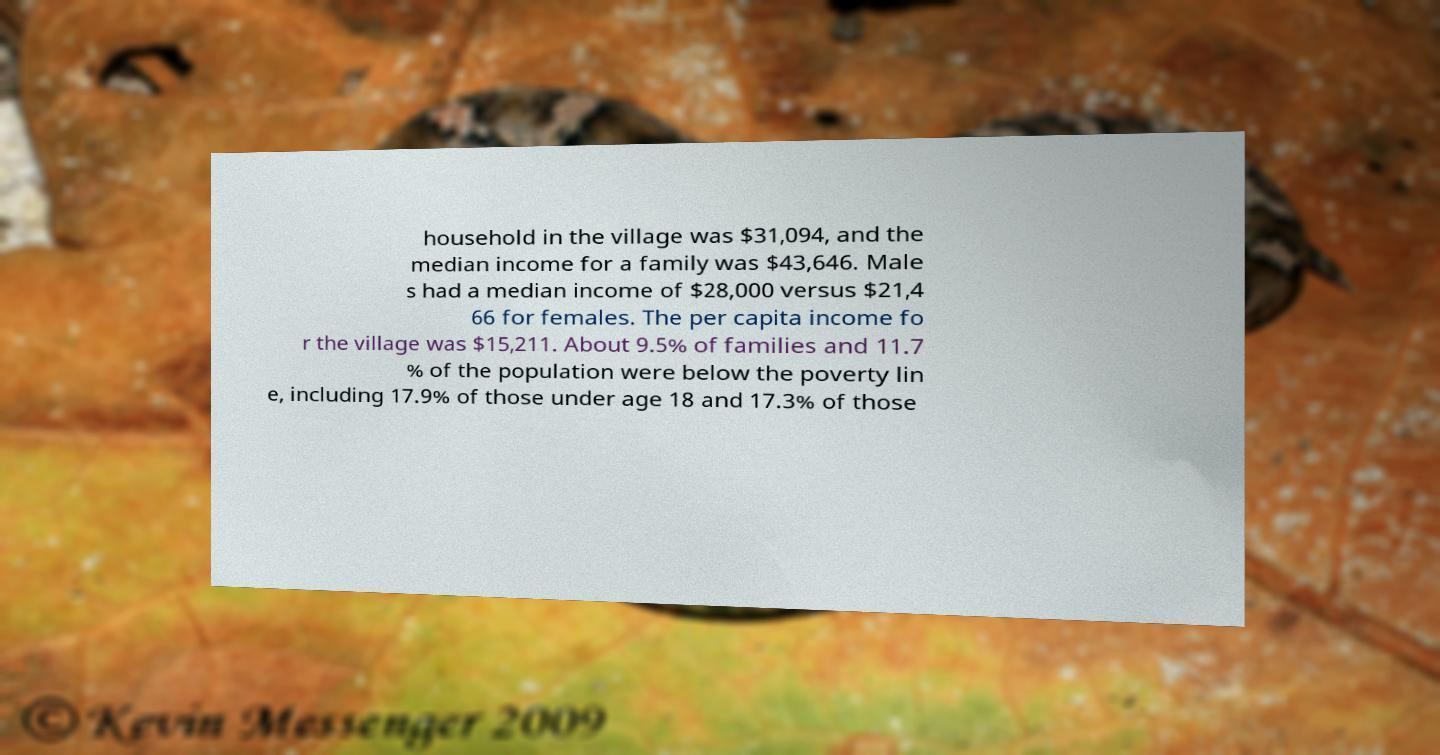For documentation purposes, I need the text within this image transcribed. Could you provide that? household in the village was $31,094, and the median income for a family was $43,646. Male s had a median income of $28,000 versus $21,4 66 for females. The per capita income fo r the village was $15,211. About 9.5% of families and 11.7 % of the population were below the poverty lin e, including 17.9% of those under age 18 and 17.3% of those 